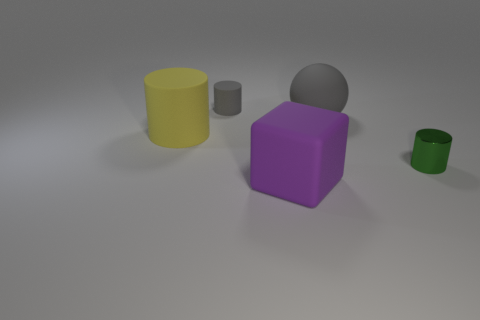There is a purple matte thing that is the same size as the yellow matte cylinder; what shape is it?
Your response must be concise. Cube. Are there more big yellow rubber objects than big green matte cylinders?
Ensure brevity in your answer.  Yes. What is the thing that is to the right of the small gray cylinder and behind the big yellow matte cylinder made of?
Your answer should be compact. Rubber. What number of other objects are the same material as the green cylinder?
Offer a terse response. 0. How many large things are the same color as the large cube?
Your answer should be very brief. 0. What is the size of the rubber thing in front of the small cylinder in front of the gray matte thing on the left side of the big purple cube?
Provide a short and direct response. Large. What number of metallic things are tiny spheres or yellow things?
Offer a very short reply. 0. There is a big purple thing; is it the same shape as the small object to the left of the big rubber cube?
Your answer should be compact. No. Is the number of large purple rubber cubes that are in front of the large purple object greater than the number of purple blocks right of the gray matte sphere?
Ensure brevity in your answer.  No. Is there any other thing that is the same color as the metallic object?
Your answer should be very brief. No. 